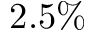Convert formula to latex. <formula><loc_0><loc_0><loc_500><loc_500>2 . 5 \%</formula> 